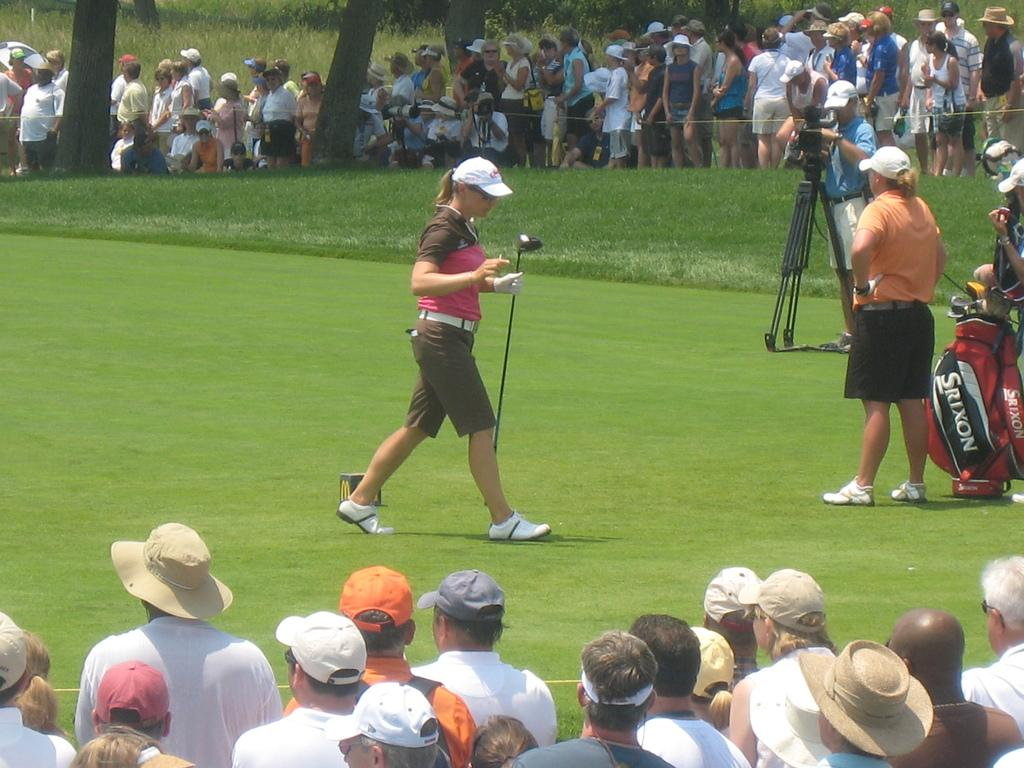<image>
Create a compact narrative representing the image presented. a golf course with a woman in orange standing near her srixon golf bag 